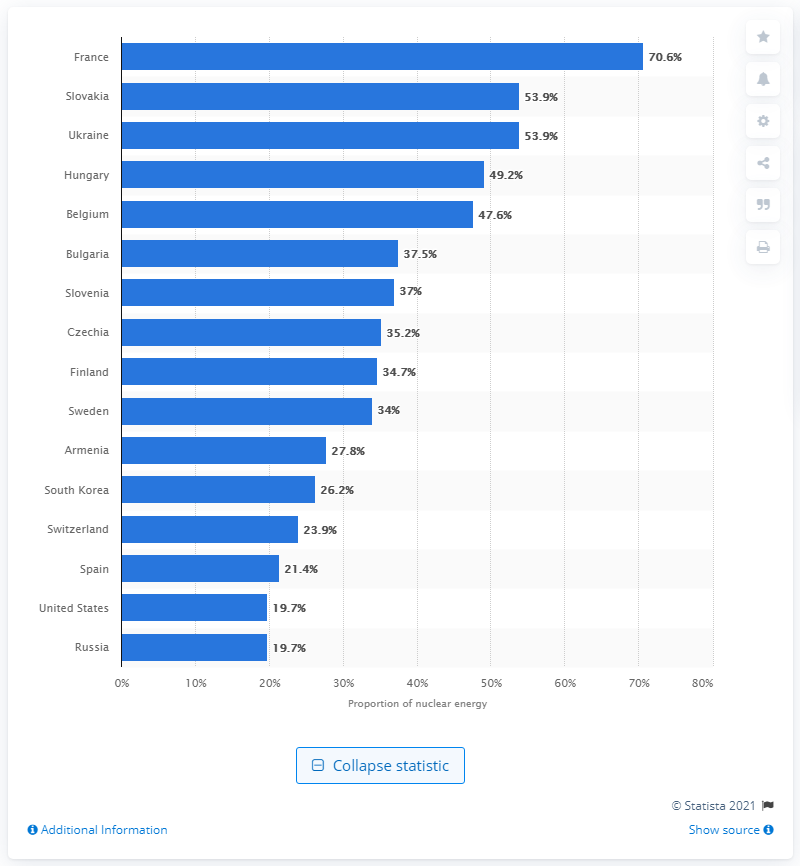List a handful of essential elements in this visual. In 2019, nuclear energy accounted for 70.6% of France's total energy production. France leads the world in its reliance on nuclear power for electricity generation, accounting for the greatest share of any country. 